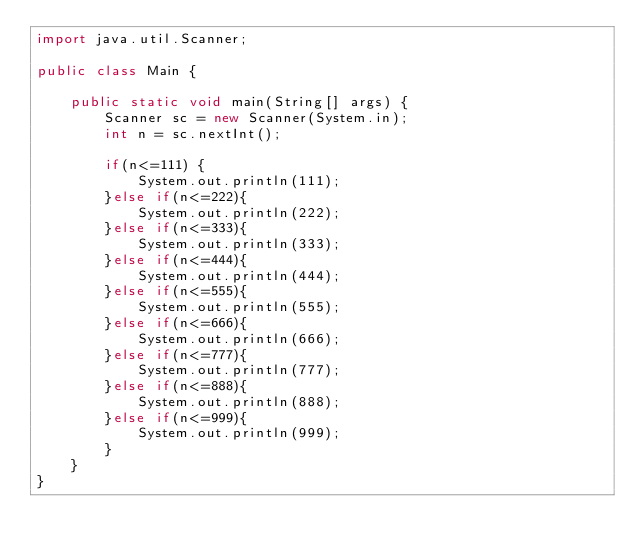<code> <loc_0><loc_0><loc_500><loc_500><_Java_>import java.util.Scanner;

public class Main {

	public static void main(String[] args) {
		Scanner sc = new Scanner(System.in);
		int n = sc.nextInt();

		if(n<=111) {
			System.out.println(111);
		}else if(n<=222){
			System.out.println(222);
		}else if(n<=333){
			System.out.println(333);
		}else if(n<=444){
			System.out.println(444);
		}else if(n<=555){
			System.out.println(555);
		}else if(n<=666){
			System.out.println(666);
		}else if(n<=777){
			System.out.println(777);
		}else if(n<=888){
			System.out.println(888);
		}else if(n<=999){
			System.out.println(999);
		}
	}
}


</code> 